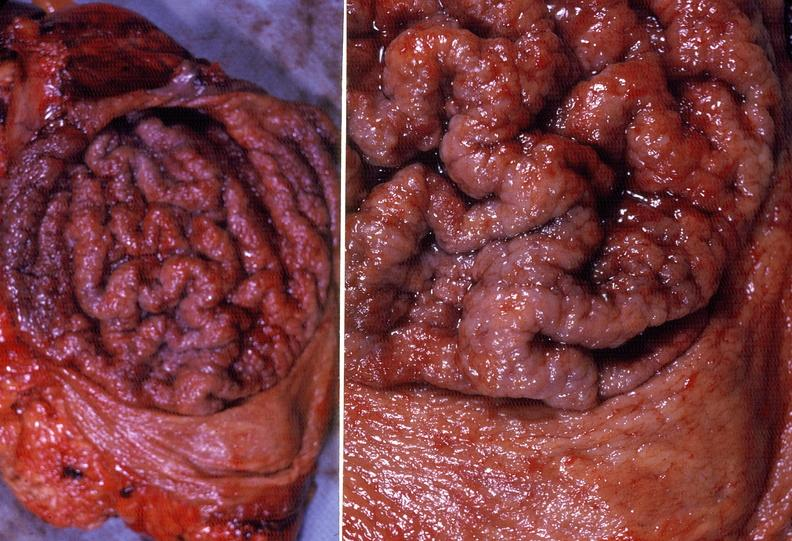where does this belong to?
Answer the question using a single word or phrase. Gastrointestinal system 